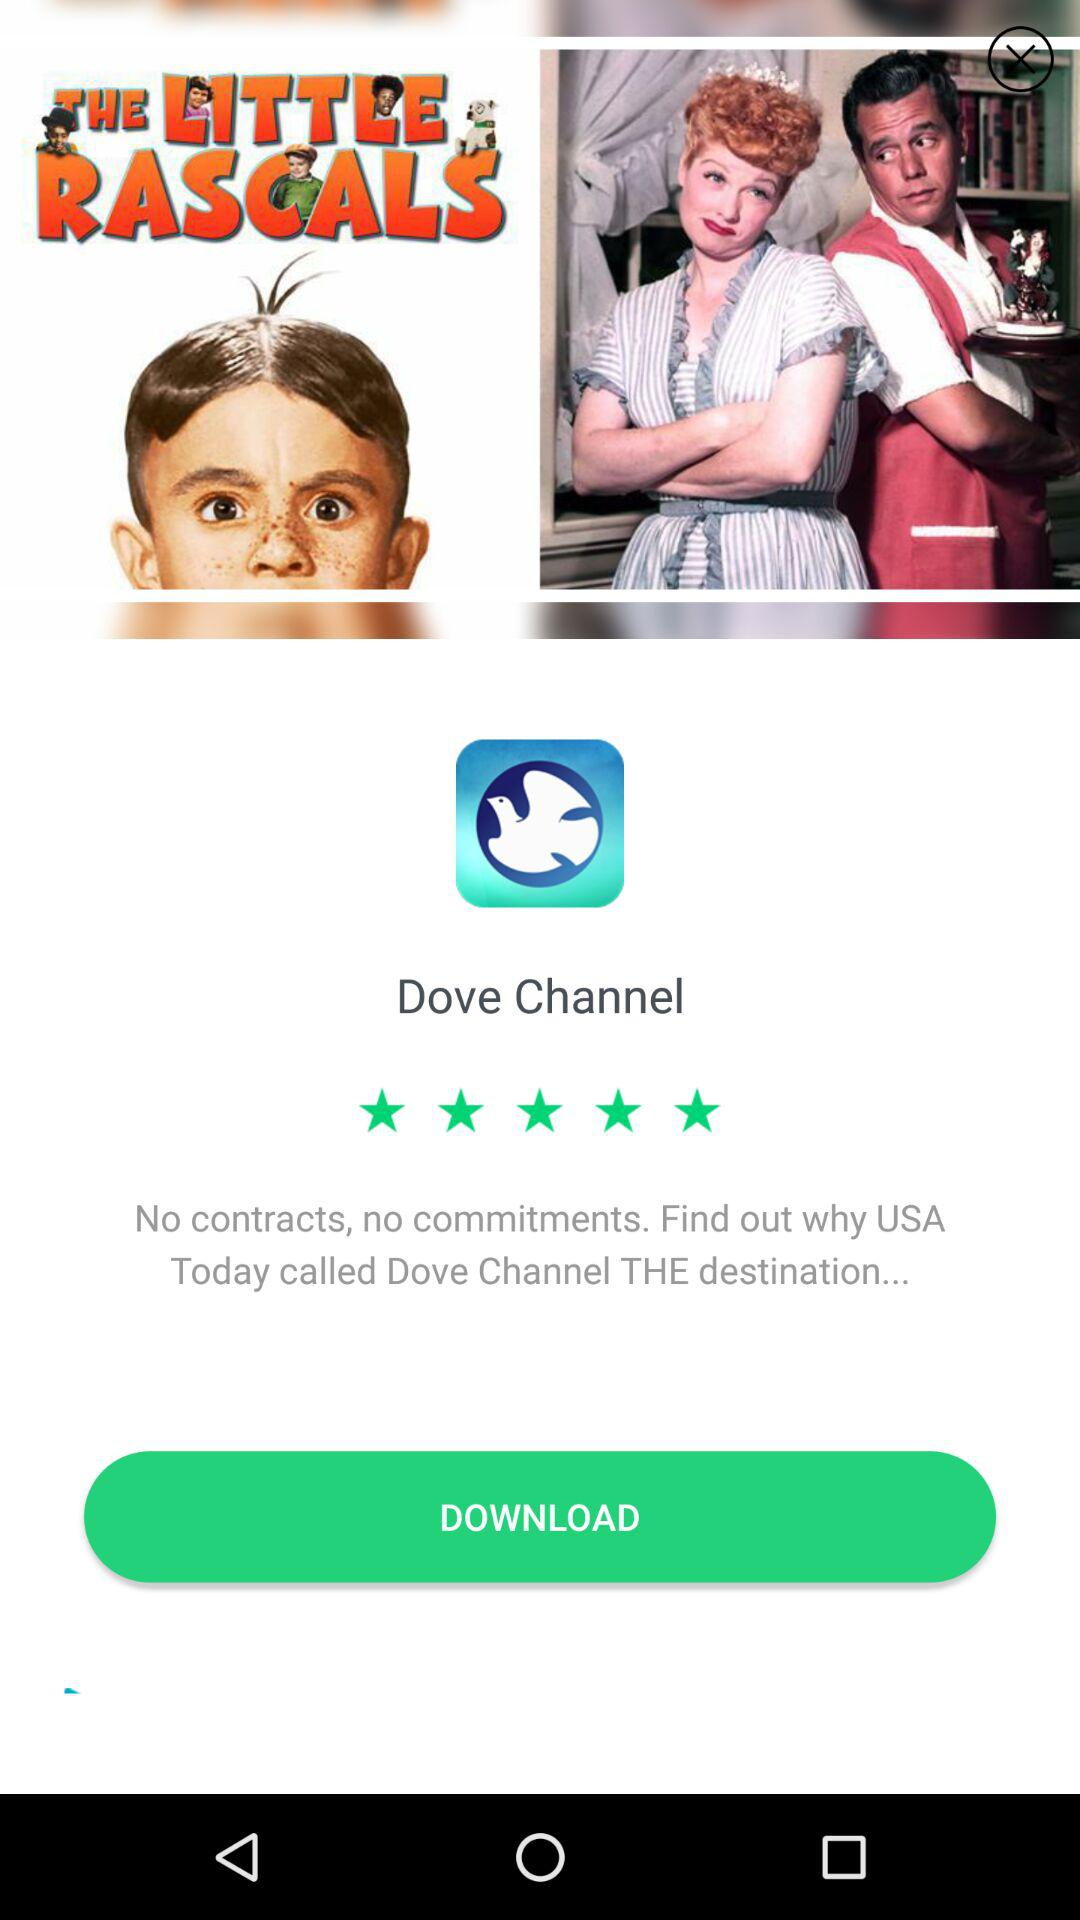How many stars did the application get? The application got 5 stars. 